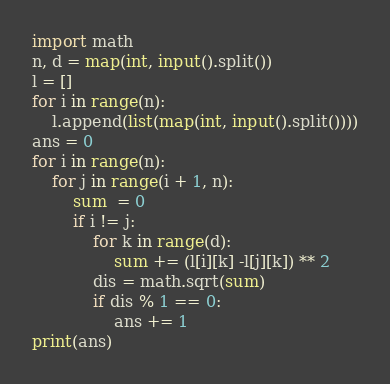Convert code to text. <code><loc_0><loc_0><loc_500><loc_500><_Python_>import math
n, d = map(int, input().split())
l = []
for i in range(n):
    l.append(list(map(int, input().split())))
ans = 0
for i in range(n):
    for j in range(i + 1, n):
        sum  = 0
        if i != j:
            for k in range(d):
                sum += (l[i][k] -l[j][k]) ** 2
            dis = math.sqrt(sum)
            if dis % 1 == 0:
                ans += 1
print(ans)</code> 